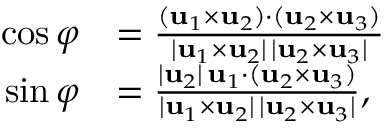Convert formula to latex. <formula><loc_0><loc_0><loc_500><loc_500>{ \begin{array} { r l } { \cos \varphi } & { = { \frac { ( u _ { 1 } \times u _ { 2 } ) \cdot ( u _ { 2 } \times u _ { 3 } ) } { | u _ { 1 } \times u _ { 2 } | \, | u _ { 2 } \times u _ { 3 } | } } } \\ { \sin \varphi } & { = { \frac { | u _ { 2 } | \, u _ { 1 } \cdot ( u _ { 2 } \times u _ { 3 } ) } { | u _ { 1 } \times u _ { 2 } | \, | u _ { 2 } \times u _ { 3 } | } } , } \end{array} }</formula> 